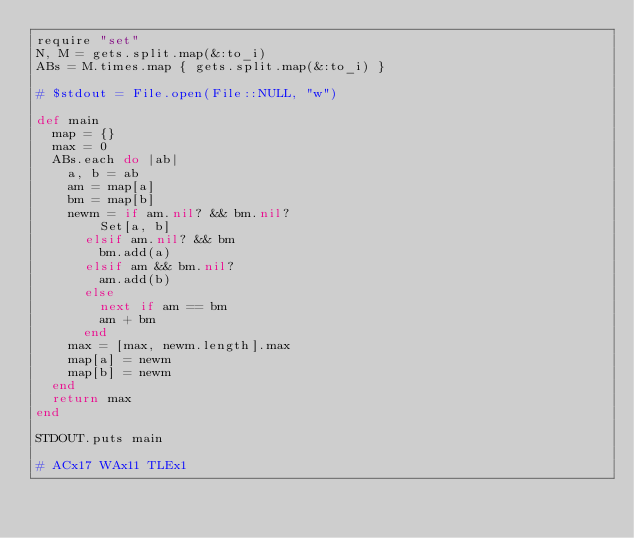Convert code to text. <code><loc_0><loc_0><loc_500><loc_500><_Ruby_>require "set"
N, M = gets.split.map(&:to_i)
ABs = M.times.map { gets.split.map(&:to_i) }

# $stdout = File.open(File::NULL, "w")

def main
  map = {}
  max = 0
  ABs.each do |ab|
    a, b = ab
    am = map[a]
    bm = map[b]
    newm = if am.nil? && bm.nil?
        Set[a, b]
      elsif am.nil? && bm
        bm.add(a)
      elsif am && bm.nil?
        am.add(b)
      else
        next if am == bm
        am + bm
      end
    max = [max, newm.length].max
    map[a] = newm
    map[b] = newm
  end
  return max
end

STDOUT.puts main

# ACx17 WAx11 TLEx1
</code> 